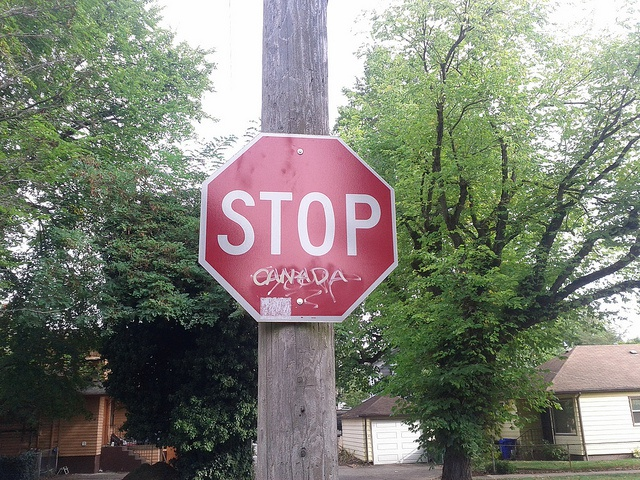Describe the objects in this image and their specific colors. I can see a stop sign in gray, lightpink, brown, and lavender tones in this image. 